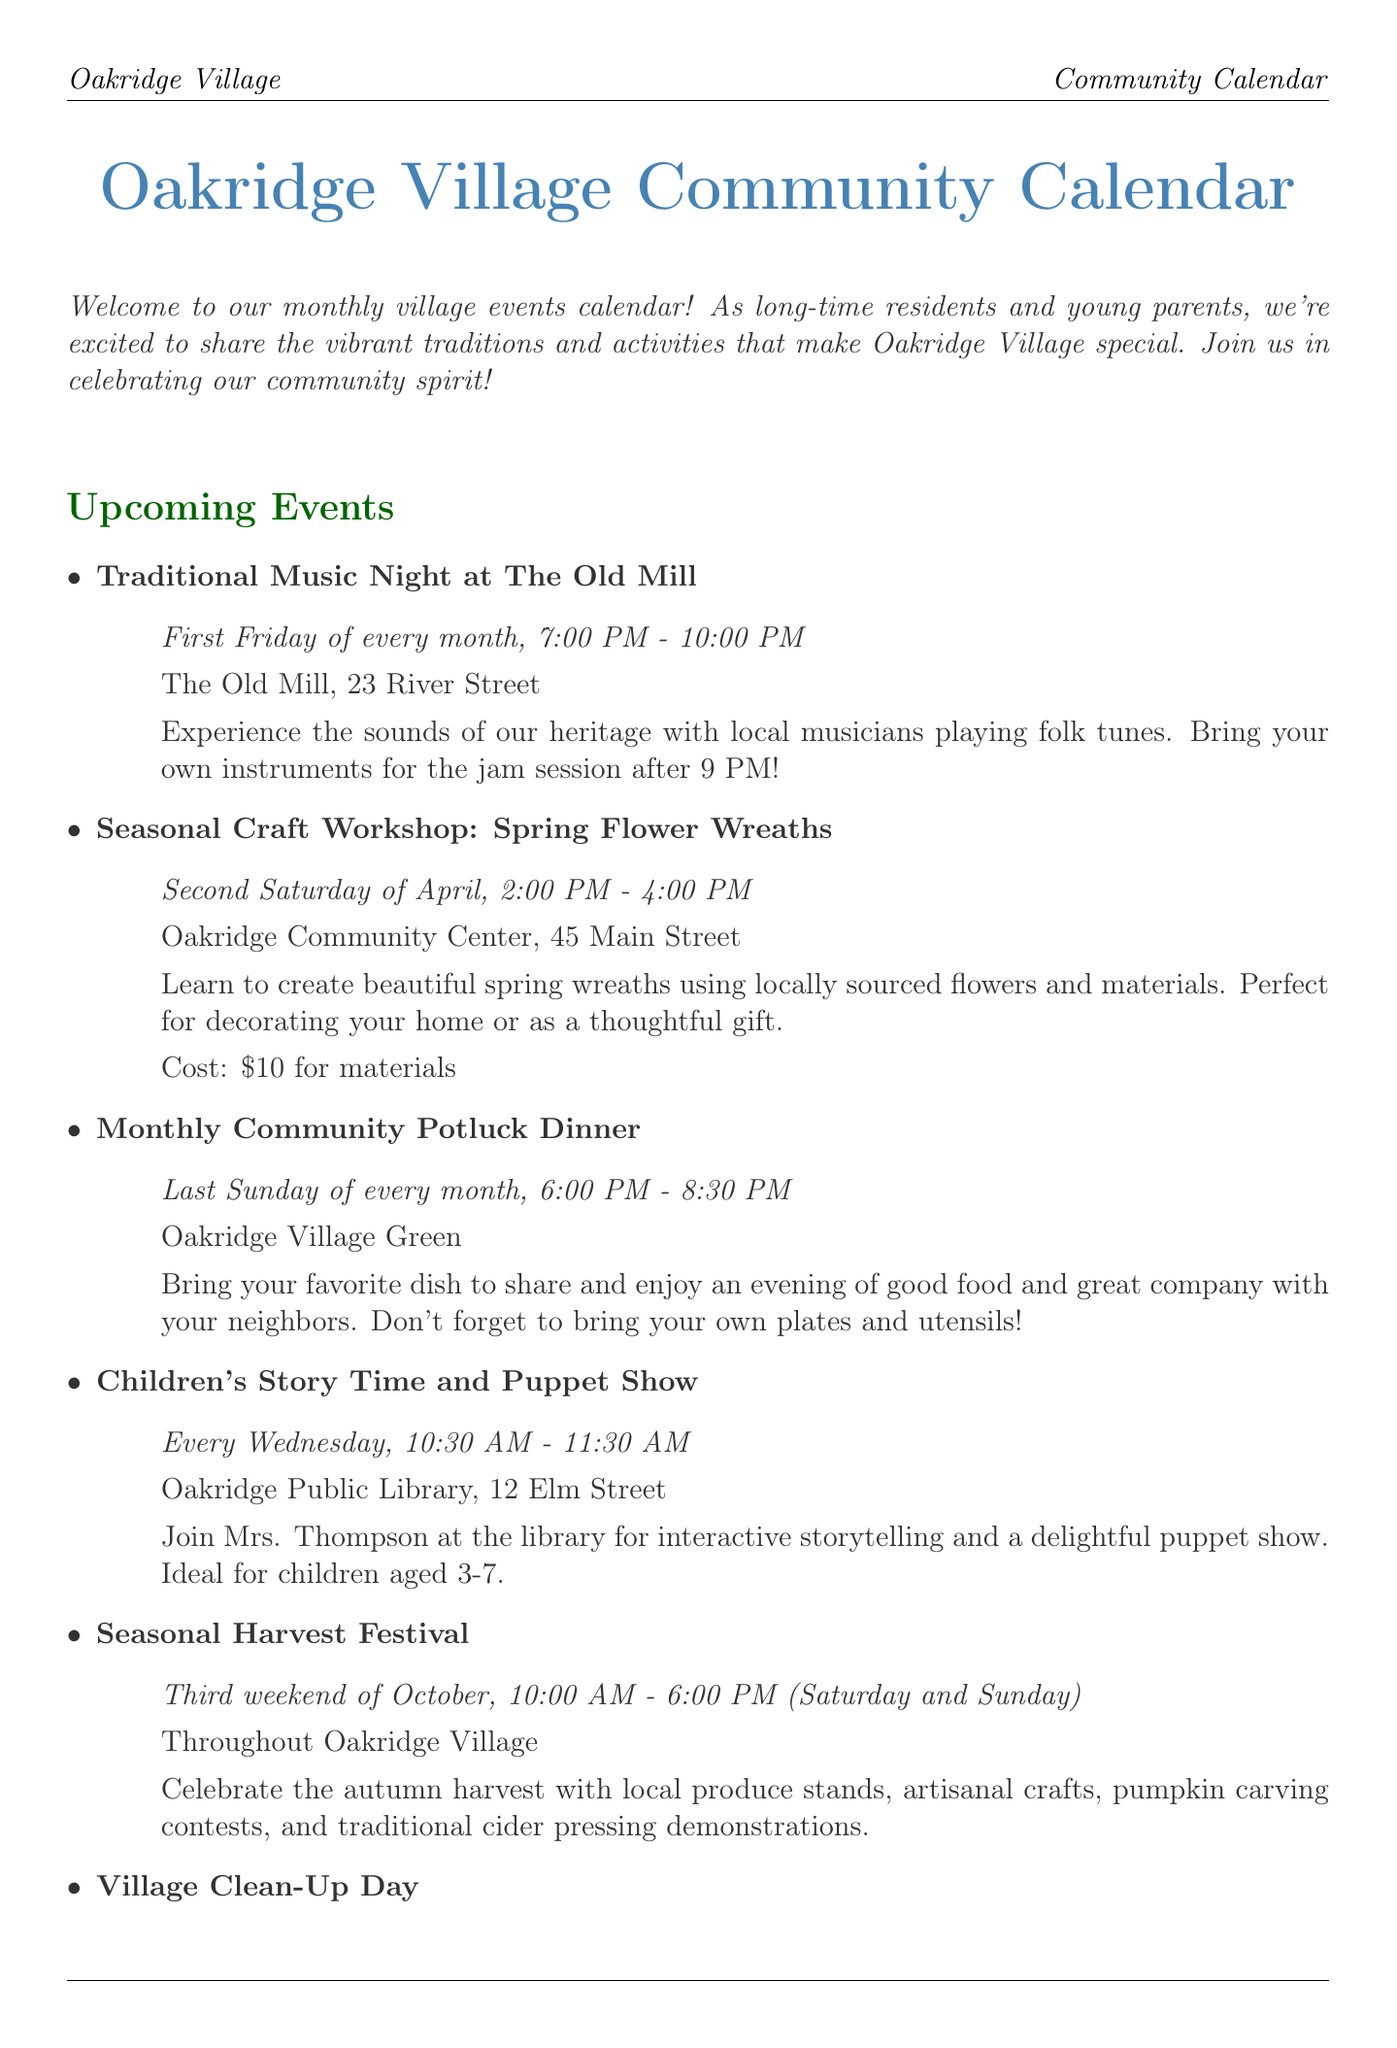What is the title of the newsletter? The title is explicitly stated at the beginning of the document as the main title.
Answer: Oakridge Village Community Calendar When does the Traditional Music Night occur? The document specifies this event's recurrence in the event details.
Answer: First Friday of every month How much does the Seasonal Craft Workshop cost? The cost is mentioned in the description of the workshop event.
Answer: $10 for materials Where is the Children's Story Time held? The location is provided in the event details for the storytelling session.
Answer: Oakridge Public Library, 12 Elm Street What is the date for the Monthly Community Potluck Dinner? The specific day of the month this event occurs is stated clearly in the event description.
Answer: Last Sunday of every month How often does the Oakridge Farmers' Market take place? The frequency of this market is described in the ongoing activities section.
Answer: Every Saturday What activity is scheduled for Tuesday evenings? The document outlines the evening event type under ongoing activities.
Answer: Adult Folk Dance Classes What is the main purpose of the New Parent Support Group? The document describes the intention behind this group's establishment.
Answer: Informal chats and support What should you bring to the Monthly Community Potluck Dinner? This detail is mentioned in the description of the potluck event.
Answer: Your favorite dish, plates, and utensils 